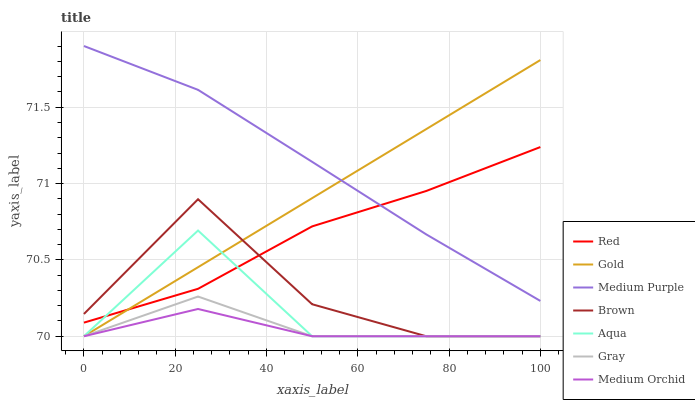Does Medium Orchid have the minimum area under the curve?
Answer yes or no. Yes. Does Medium Purple have the maximum area under the curve?
Answer yes or no. Yes. Does Gold have the minimum area under the curve?
Answer yes or no. No. Does Gold have the maximum area under the curve?
Answer yes or no. No. Is Gold the smoothest?
Answer yes or no. Yes. Is Brown the roughest?
Answer yes or no. Yes. Is Gray the smoothest?
Answer yes or no. No. Is Gray the roughest?
Answer yes or no. No. Does Brown have the lowest value?
Answer yes or no. Yes. Does Medium Purple have the lowest value?
Answer yes or no. No. Does Medium Purple have the highest value?
Answer yes or no. Yes. Does Gold have the highest value?
Answer yes or no. No. Is Brown less than Medium Purple?
Answer yes or no. Yes. Is Medium Purple greater than Medium Orchid?
Answer yes or no. Yes. Does Medium Purple intersect Gold?
Answer yes or no. Yes. Is Medium Purple less than Gold?
Answer yes or no. No. Is Medium Purple greater than Gold?
Answer yes or no. No. Does Brown intersect Medium Purple?
Answer yes or no. No. 